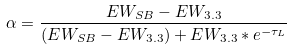Convert formula to latex. <formula><loc_0><loc_0><loc_500><loc_500>\alpha = \frac { E W _ { S B } - E W _ { 3 . 3 } } { ( E W _ { S B } - E W _ { 3 . 3 } ) + E W _ { 3 . 3 } * e ^ { - \tau _ { L } } }</formula> 